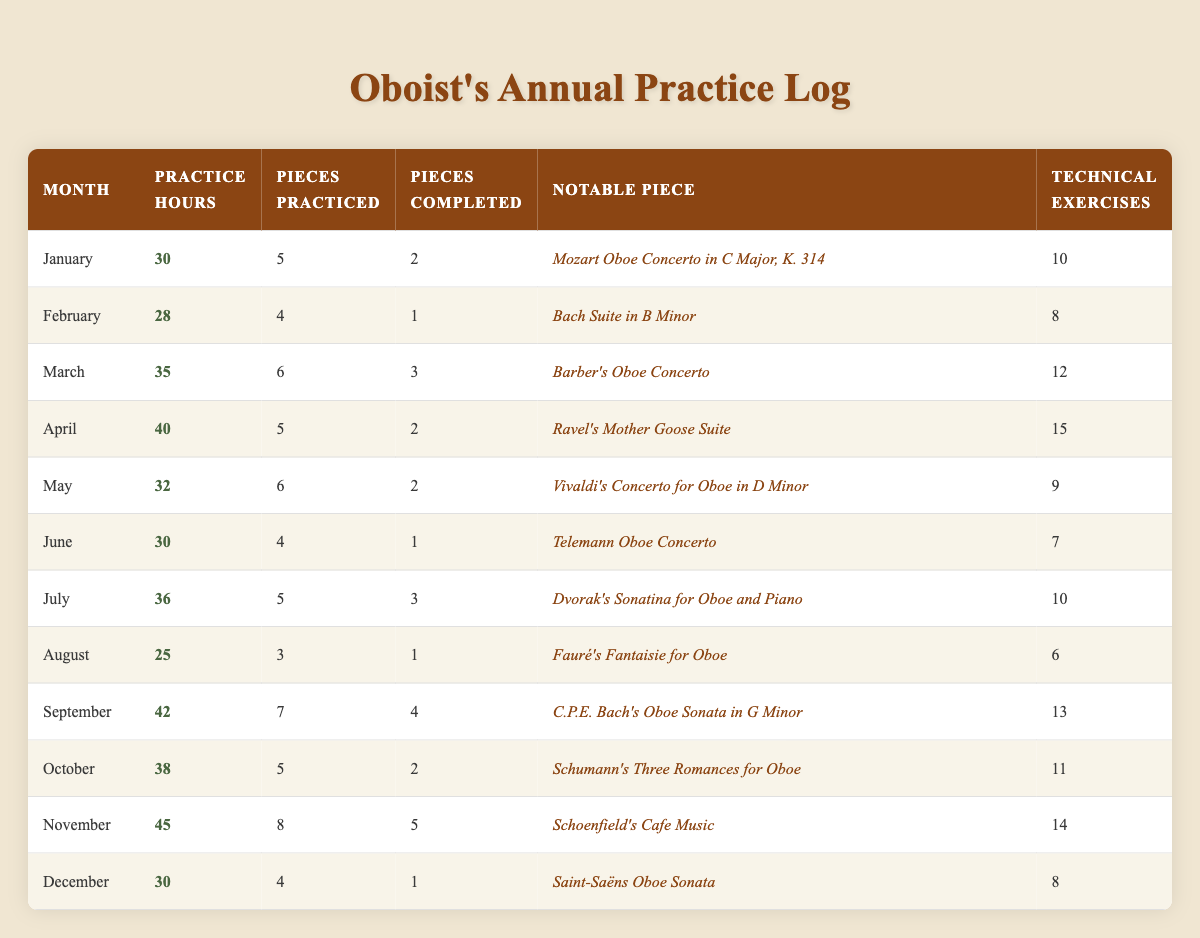What is the notable piece practiced in January? The table lists the notable pieces practiced in each month. For January, the notable piece is "Mozart Oboe Concerto in C Major, K. 314."
Answer: Mozart Oboe Concerto in C Major, K. 314 How many hours were practiced in November? The table indicates the practice hours for each month. In November, the practice hours recorded are 45.
Answer: 45 In which month were the most pieces completed? By reviewing the 'Pieces Completed' column, we find that November has the highest number of completed pieces at 5.
Answer: November What is the average number of technical exercises practiced per month? To find this, sum the technical exercises (10 + 8 + 12 + 15 + 9 + 7 + 10 + 6 + 13 + 11 + 14 + 8 =  12.25) over 12 months and then divide by 12 to get the average. Total = 143, so the average is 143/12 = 11.92.
Answer: Approximately 11.92 Which month had the least practice hours? By scanning the 'Practice Hours' column, August has the least practice hours at 25.
Answer: August Was there ever a month where more than 40 practice hours were logged? Looking at the practice hours, there are months recorded with practice hours above 40: April (40), September (42), and November (45). Thus, the answer is yes.
Answer: Yes What is the difference in practice hours between January and September? January has 30 hours and September has 42 hours. The difference is calculated as 42 - 30 = 12 hours.
Answer: 12 hours How many pieces were practiced in March? The 'Pieces Practiced' column indicates that 6 pieces were practiced in March.
Answer: 6 Is February a month where the notable piece was composed by Bach? February's notable piece is "Bach Suite in B Minor," confirming that it is composed by Bach.
Answer: Yes What is the trend of practice hours over the months? Observing the 'Practice Hours' column, we note the following pattern: 30, 28, 35, 40, 32, 30, 36, 25, 42, 38, 45, 30. The overall trend shows fluctuations with a peak in November and a low in August.
Answer: Fluctuations with a peak in November and a low in August Which months had the highest and lowest number of pieces practiced? The highest number of pieces practiced was in November (8), while the lowest was in August (3).
Answer: Highest: November; Lowest: August 